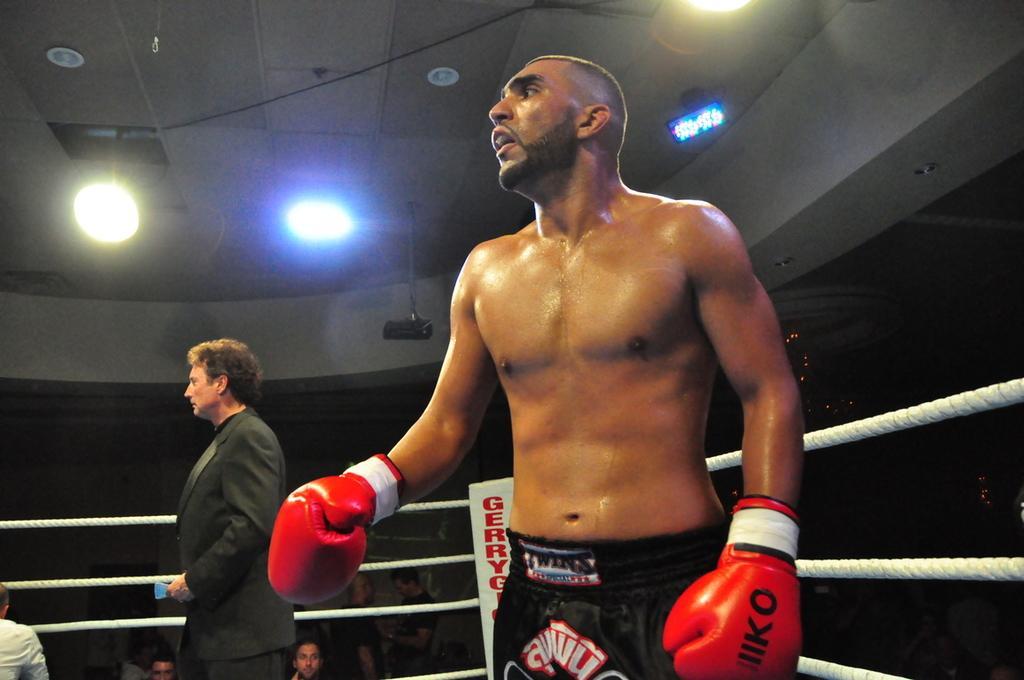Can you describe this image briefly? In the image there is a boxing player, behind him there is a man and around him there is a fencing with ropes. In the background there are a group of people. 